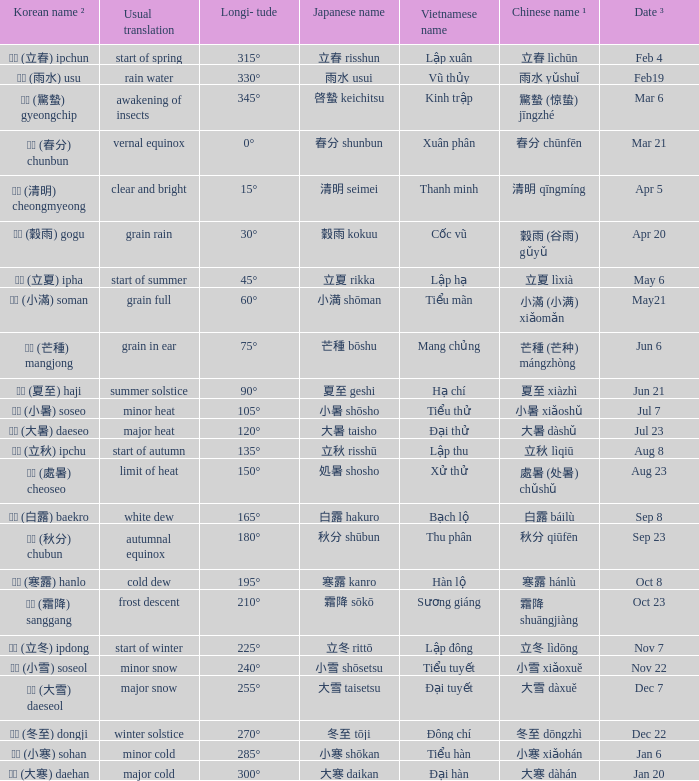Which Japanese name has a Korean name ² of 경칩 (驚蟄) gyeongchip? 啓蟄 keichitsu. Can you give me this table as a dict? {'header': ['Korean name ²', 'Usual translation', 'Longi- tude', 'Japanese name', 'Vietnamese name', 'Chinese name ¹', 'Date ³'], 'rows': [['입춘 (立春) ipchun', 'start of spring', '315°', '立春 risshun', 'Lập xuân', '立春 lìchūn', 'Feb 4'], ['우수 (雨水) usu', 'rain water', '330°', '雨水 usui', 'Vũ thủy', '雨水 yǔshuǐ', 'Feb19'], ['경칩 (驚蟄) gyeongchip', 'awakening of insects', '345°', '啓蟄 keichitsu', 'Kinh trập', '驚蟄 (惊蛰) jīngzhé', 'Mar 6'], ['춘분 (春分) chunbun', 'vernal equinox', '0°', '春分 shunbun', 'Xuân phân', '春分 chūnfēn', 'Mar 21'], ['청명 (清明) cheongmyeong', 'clear and bright', '15°', '清明 seimei', 'Thanh minh', '清明 qīngmíng', 'Apr 5'], ['곡우 (穀雨) gogu', 'grain rain', '30°', '穀雨 kokuu', 'Cốc vũ', '穀雨 (谷雨) gǔyǔ', 'Apr 20'], ['입하 (立夏) ipha', 'start of summer', '45°', '立夏 rikka', 'Lập hạ', '立夏 lìxià', 'May 6'], ['소만 (小滿) soman', 'grain full', '60°', '小満 shōman', 'Tiểu mãn', '小滿 (小满) xiǎomǎn', 'May21'], ['망종 (芒種) mangjong', 'grain in ear', '75°', '芒種 bōshu', 'Mang chủng', '芒種 (芒种) mángzhòng', 'Jun 6'], ['하지 (夏至) haji', 'summer solstice', '90°', '夏至 geshi', 'Hạ chí', '夏至 xiàzhì', 'Jun 21'], ['소서 (小暑) soseo', 'minor heat', '105°', '小暑 shōsho', 'Tiểu thử', '小暑 xiǎoshǔ', 'Jul 7'], ['대서 (大暑) daeseo', 'major heat', '120°', '大暑 taisho', 'Đại thử', '大暑 dàshǔ', 'Jul 23'], ['입추 (立秋) ipchu', 'start of autumn', '135°', '立秋 risshū', 'Lập thu', '立秋 lìqiū', 'Aug 8'], ['처서 (處暑) cheoseo', 'limit of heat', '150°', '処暑 shosho', 'Xử thử', '處暑 (处暑) chǔshǔ', 'Aug 23'], ['백로 (白露) baekro', 'white dew', '165°', '白露 hakuro', 'Bạch lộ', '白露 báilù', 'Sep 8'], ['추분 (秋分) chubun', 'autumnal equinox', '180°', '秋分 shūbun', 'Thu phân', '秋分 qiūfēn', 'Sep 23'], ['한로 (寒露) hanlo', 'cold dew', '195°', '寒露 kanro', 'Hàn lộ', '寒露 hánlù', 'Oct 8'], ['상강 (霜降) sanggang', 'frost descent', '210°', '霜降 sōkō', 'Sương giáng', '霜降 shuāngjiàng', 'Oct 23'], ['입동 (立冬) ipdong', 'start of winter', '225°', '立冬 rittō', 'Lập đông', '立冬 lìdōng', 'Nov 7'], ['소설 (小雪) soseol', 'minor snow', '240°', '小雪 shōsetsu', 'Tiểu tuyết', '小雪 xiǎoxuě', 'Nov 22'], ['대설 (大雪) daeseol', 'major snow', '255°', '大雪 taisetsu', 'Đại tuyết', '大雪 dàxuě', 'Dec 7'], ['동지 (冬至) dongji', 'winter solstice', '270°', '冬至 tōji', 'Đông chí', '冬至 dōngzhì', 'Dec 22'], ['소한 (小寒) sohan', 'minor cold', '285°', '小寒 shōkan', 'Tiểu hàn', '小寒 xiǎohán', 'Jan 6'], ['대한 (大寒) daehan', 'major cold', '300°', '大寒 daikan', 'Đại hàn', '大寒 dàhán', 'Jan 20']]} 